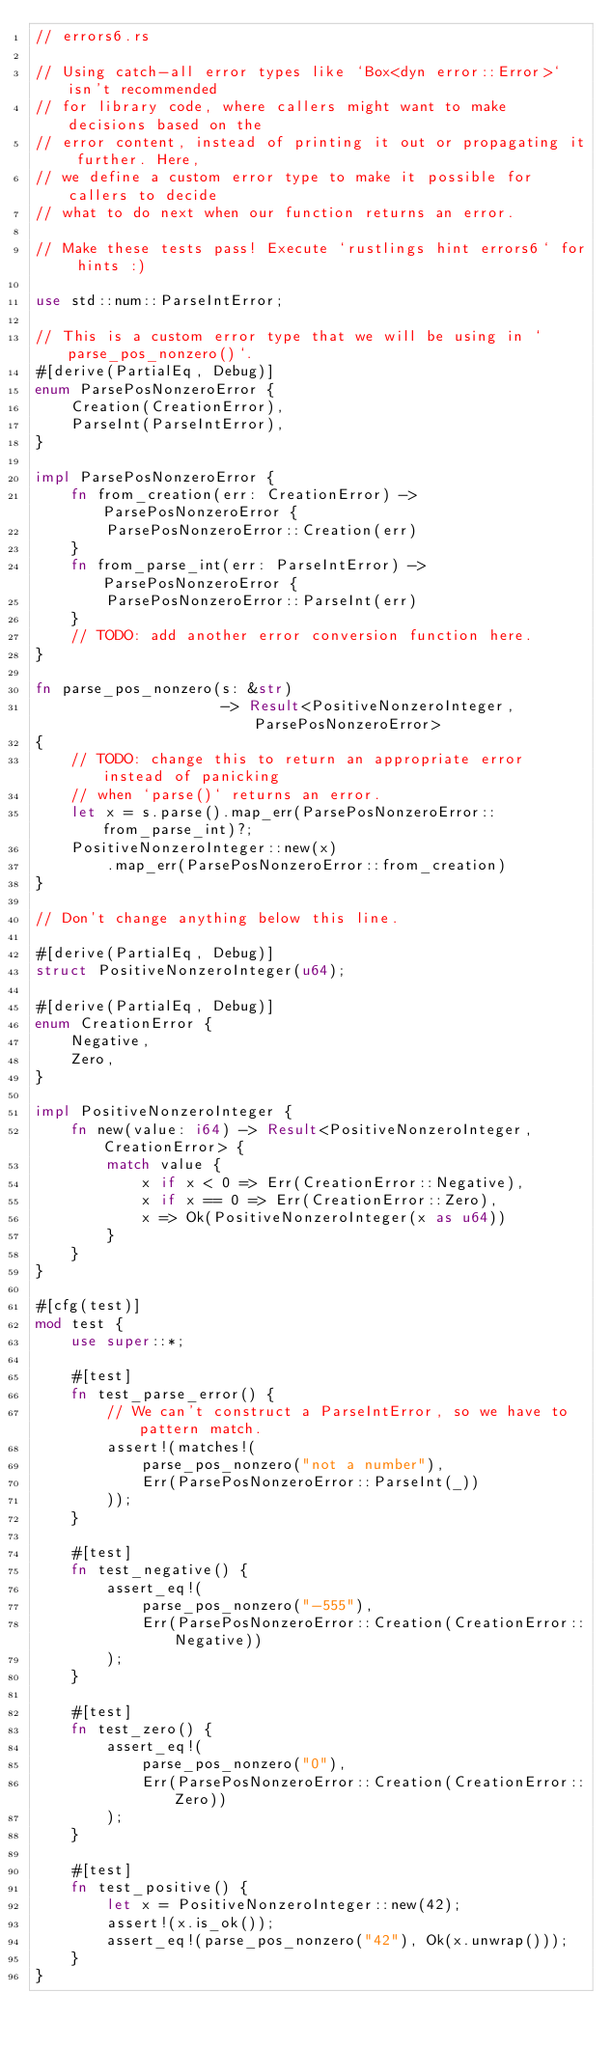<code> <loc_0><loc_0><loc_500><loc_500><_Rust_>// errors6.rs

// Using catch-all error types like `Box<dyn error::Error>` isn't recommended
// for library code, where callers might want to make decisions based on the
// error content, instead of printing it out or propagating it further. Here,
// we define a custom error type to make it possible for callers to decide
// what to do next when our function returns an error.

// Make these tests pass! Execute `rustlings hint errors6` for hints :)

use std::num::ParseIntError;

// This is a custom error type that we will be using in `parse_pos_nonzero()`.
#[derive(PartialEq, Debug)]
enum ParsePosNonzeroError {
    Creation(CreationError),
    ParseInt(ParseIntError),
}

impl ParsePosNonzeroError {
    fn from_creation(err: CreationError) -> ParsePosNonzeroError {
        ParsePosNonzeroError::Creation(err)
    }
    fn from_parse_int(err: ParseIntError) -> ParsePosNonzeroError {
        ParsePosNonzeroError::ParseInt(err)
    }
    // TODO: add another error conversion function here.
}

fn parse_pos_nonzero(s: &str)
                     -> Result<PositiveNonzeroInteger, ParsePosNonzeroError>
{
    // TODO: change this to return an appropriate error instead of panicking
    // when `parse()` returns an error.
    let x = s.parse().map_err(ParsePosNonzeroError::from_parse_int)?;
    PositiveNonzeroInteger::new(x)
        .map_err(ParsePosNonzeroError::from_creation)
}

// Don't change anything below this line.

#[derive(PartialEq, Debug)]
struct PositiveNonzeroInteger(u64);

#[derive(PartialEq, Debug)]
enum CreationError {
    Negative,
    Zero,
}

impl PositiveNonzeroInteger {
    fn new(value: i64) -> Result<PositiveNonzeroInteger, CreationError> {
        match value {
            x if x < 0 => Err(CreationError::Negative),
            x if x == 0 => Err(CreationError::Zero),
            x => Ok(PositiveNonzeroInteger(x as u64))
        }
    }
}

#[cfg(test)]
mod test {
    use super::*;

    #[test]
    fn test_parse_error() {
        // We can't construct a ParseIntError, so we have to pattern match.
        assert!(matches!(
            parse_pos_nonzero("not a number"),
            Err(ParsePosNonzeroError::ParseInt(_))
        ));
    }

    #[test]
    fn test_negative() {
        assert_eq!(
            parse_pos_nonzero("-555"),
            Err(ParsePosNonzeroError::Creation(CreationError::Negative))
        );
    }

    #[test]
    fn test_zero() {
        assert_eq!(
            parse_pos_nonzero("0"),
            Err(ParsePosNonzeroError::Creation(CreationError::Zero))
        );
    }

    #[test]
    fn test_positive() {
        let x = PositiveNonzeroInteger::new(42);
        assert!(x.is_ok());
        assert_eq!(parse_pos_nonzero("42"), Ok(x.unwrap()));
    }
}
</code> 